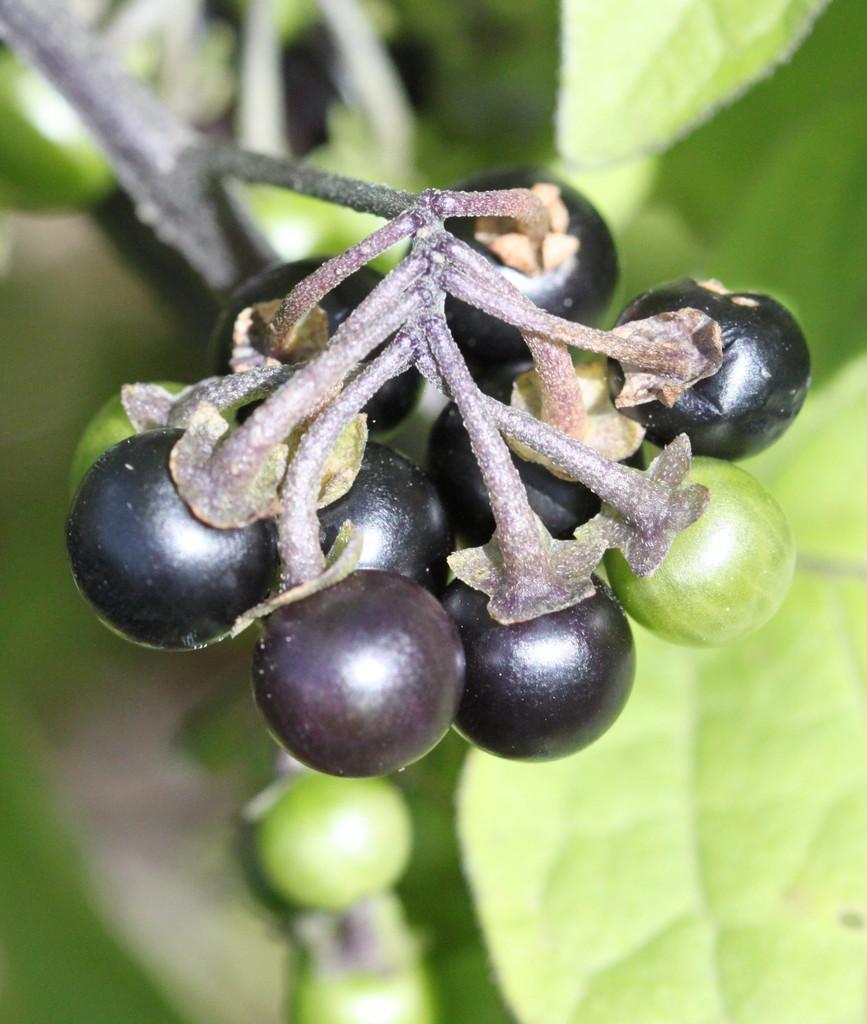Could you give a brief overview of what you see in this image? In this image we can see group of fruits on the stem of a plant. 